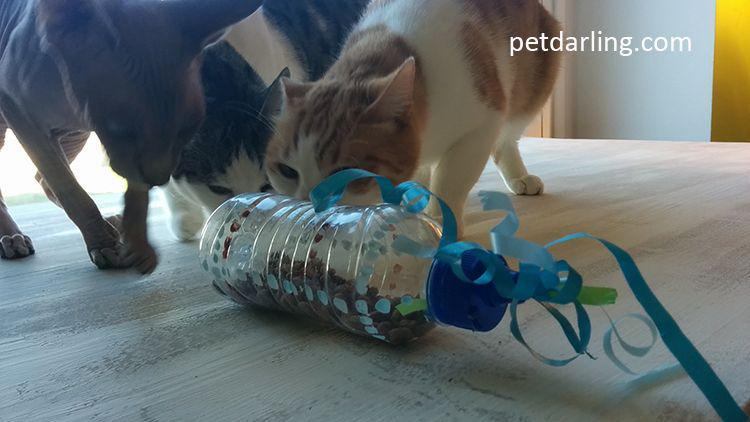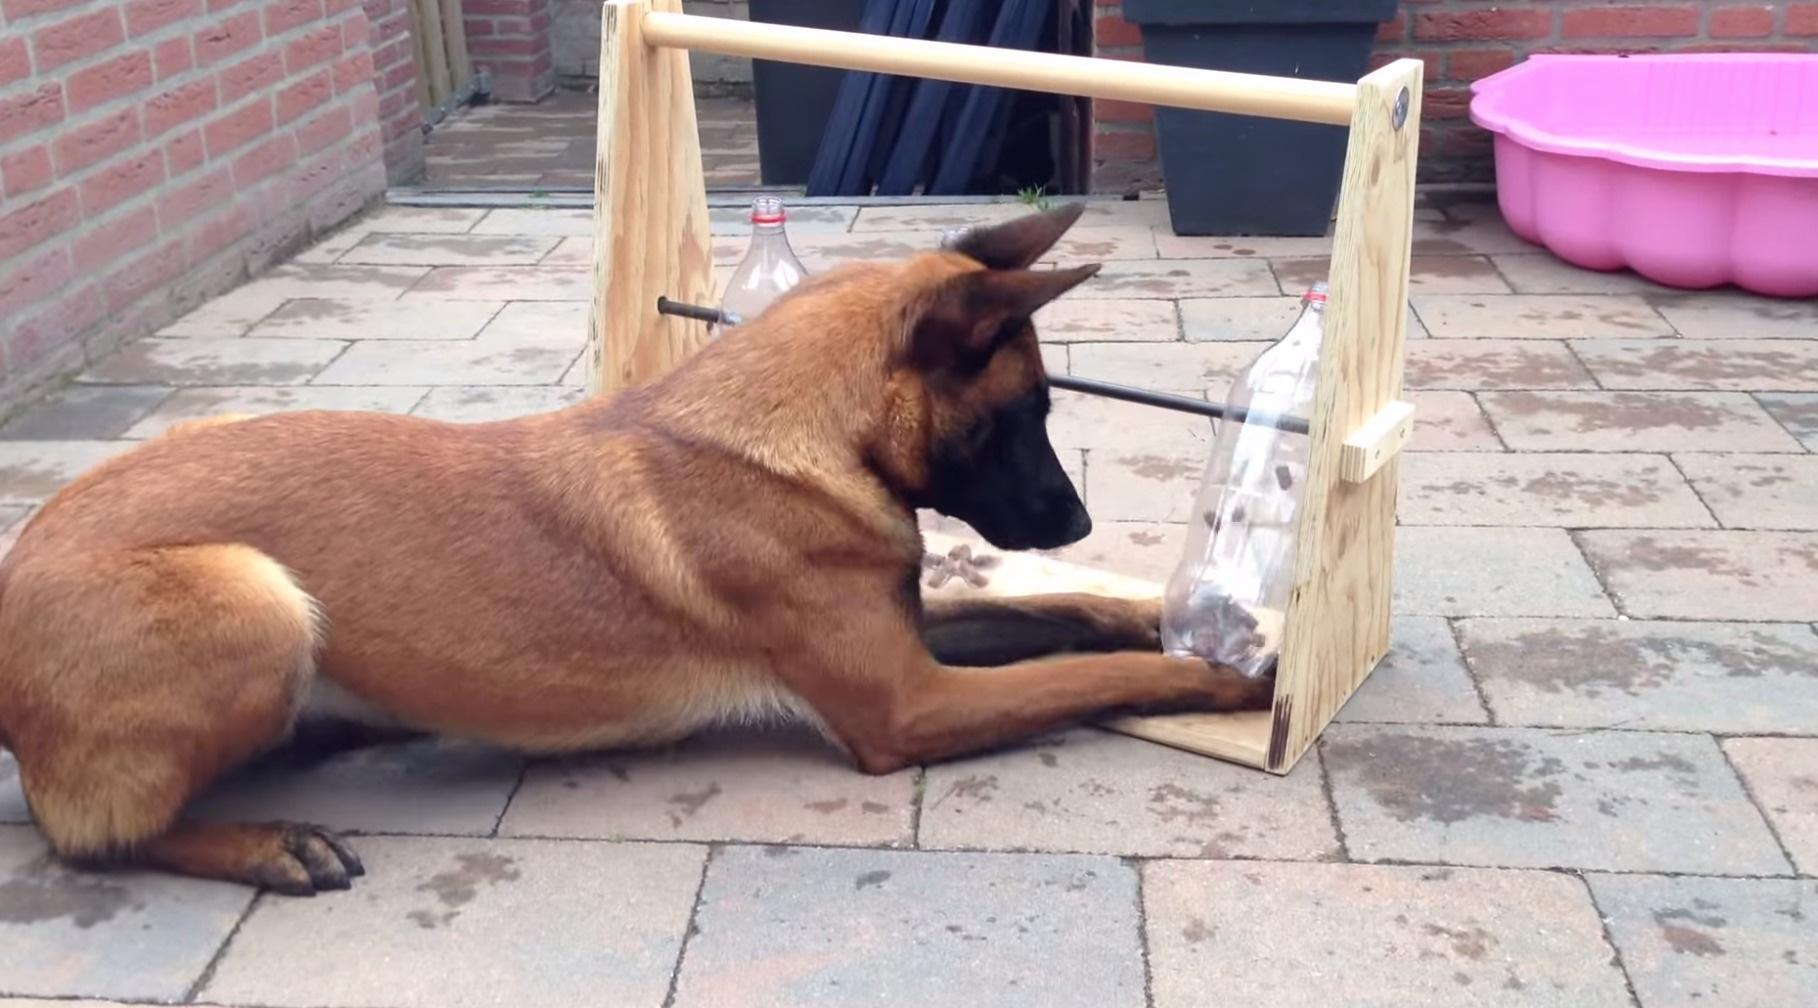The first image is the image on the left, the second image is the image on the right. Examine the images to the left and right. Is the description "An image shows a cat crouched behind a bottle trimmed with blue curly ribbon." accurate? Answer yes or no. Yes. The first image is the image on the left, the second image is the image on the right. Examine the images to the left and right. Is the description "A cat is rolling a bottle on the floor in one of the images." accurate? Answer yes or no. Yes. 